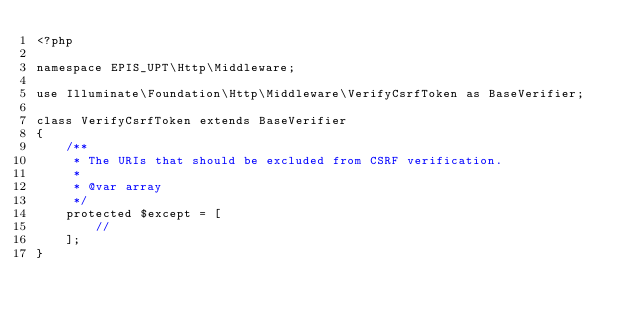<code> <loc_0><loc_0><loc_500><loc_500><_PHP_><?php

namespace EPIS_UPT\Http\Middleware;

use Illuminate\Foundation\Http\Middleware\VerifyCsrfToken as BaseVerifier;

class VerifyCsrfToken extends BaseVerifier
{
    /**
     * The URIs that should be excluded from CSRF verification.
     *
     * @var array
     */
    protected $except = [
        //
    ];
}
</code> 